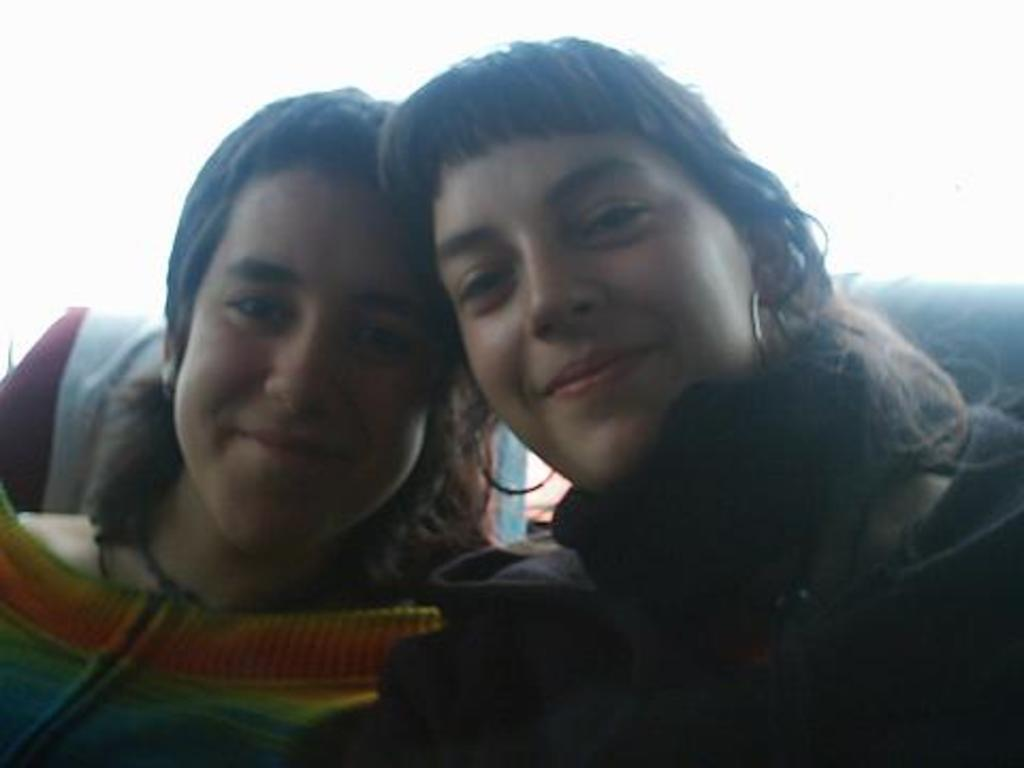How many individuals are present in the image? There are two people in the image. What type of scent can be detected from the people in the image? There is no information about the scent of the people in the image, so it cannot be determined from the picture. 